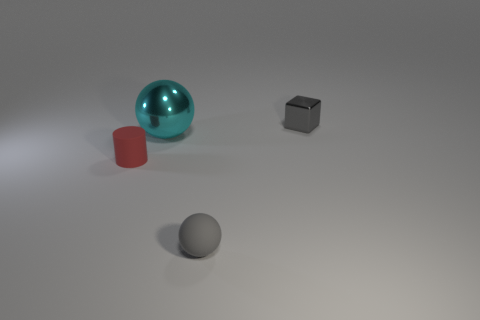Does the cylinder have the same color as the rubber thing that is to the right of the cyan thing?
Your answer should be compact. No. What number of things are tiny gray objects to the left of the tiny block or small gray objects that are behind the small gray matte thing?
Give a very brief answer. 2. There is a sphere that is the same size as the rubber cylinder; what is it made of?
Provide a succinct answer. Rubber. How many other objects are the same material as the small red thing?
Ensure brevity in your answer.  1. There is a small object behind the tiny red cylinder; does it have the same shape as the matte thing to the left of the small gray rubber ball?
Provide a short and direct response. No. What is the color of the metallic object in front of the gray object behind the small gray object in front of the big cyan thing?
Give a very brief answer. Cyan. What number of other things are the same color as the small block?
Offer a very short reply. 1. Are there fewer big green matte cylinders than large cyan spheres?
Offer a very short reply. Yes. There is a object that is both left of the small ball and to the right of the tiny red thing; what is its color?
Your answer should be compact. Cyan. There is another gray object that is the same shape as the large thing; what material is it?
Make the answer very short. Rubber. 